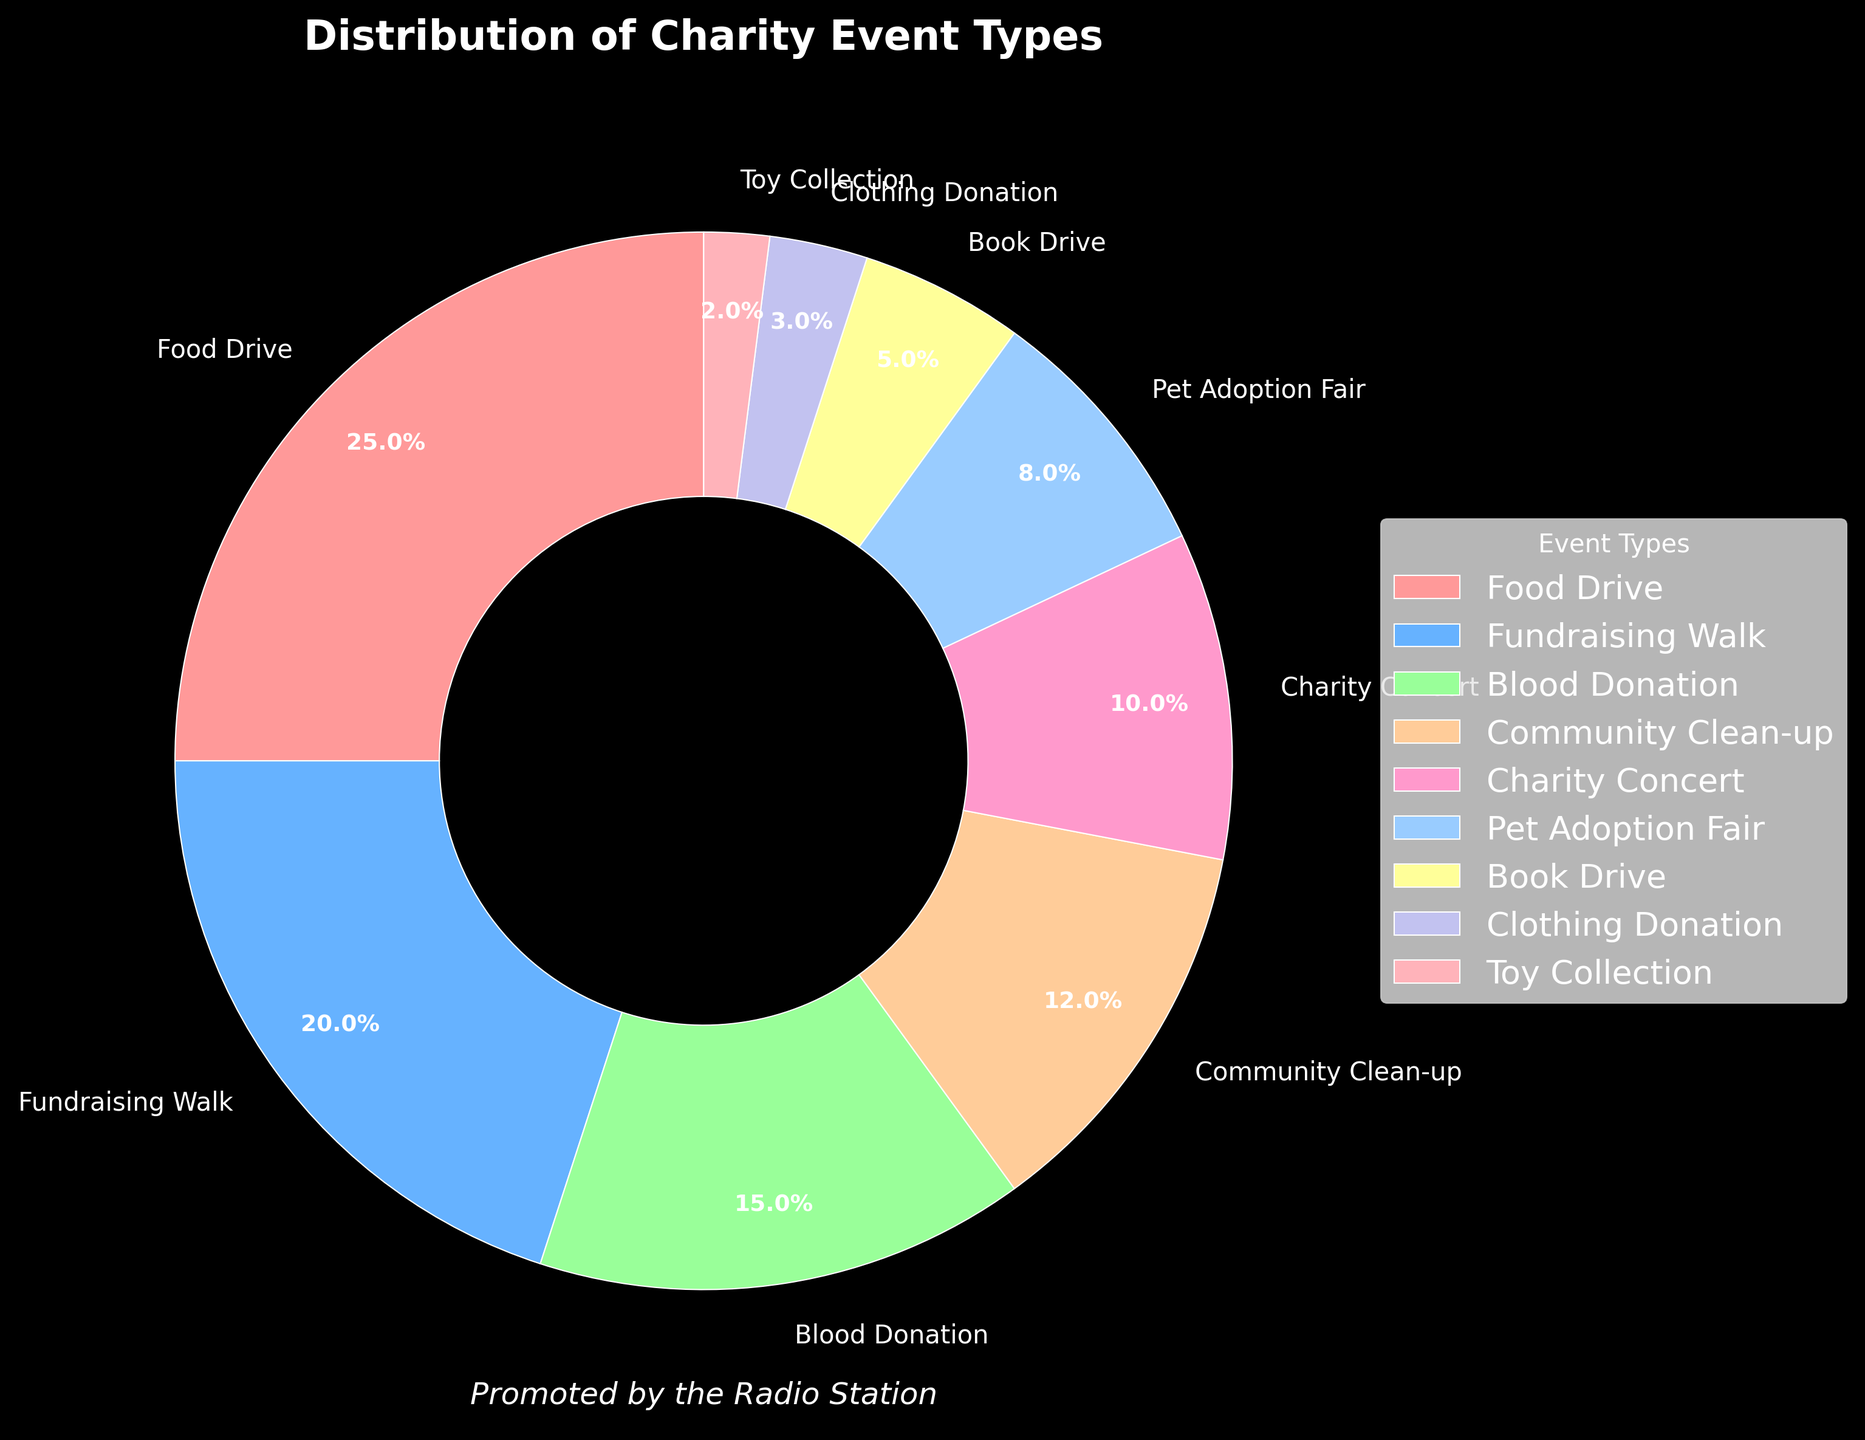What type of charity event has the highest percentage? The pie chart shows different charity event types with their respective percentage values. Observing the figure, "Food Drive" has the highest percentage of 25%.
Answer: Food Drive Compare the percentages of "Blood Donation" and "Charity Concert". Which type of event has a higher percentage and by how much? According to the pie chart, "Blood Donation" has 15% and "Charity Concert" has 10%. The difference between them is 15% - 10% = 5%.
Answer: Blood Donation by 5% What is the total percentage of Community Clean-up and Pet Adoption Fair combined? To find the total percentage of both events, sum their individual percentages. Community Clean-up is 12% and Pet Adoption Fair is 8%. Therefore, 12% + 8% = 20%.
Answer: 20% Which charity event type is represented by the pink wedge in the pie chart? The pink wedge on the pie chart corresponds to the "Food Drive", which is the event type with the highest percentage.
Answer: Food Drive How many event types have a percentage greater than or equal to 10%? List them. Observing the pie chart, the event types that meet this criterion are "Food Drive" (25%), "Fundraising Walk" (20%), "Blood Donation" (15%), "Community Clean-up" (12%), and "Charity Concert" (10%). Therefore, there are five event types.
Answer: Five: Food Drive, Fundraising Walk, Blood Donation, Community Clean-up, Charity Concert What is the difference in percentage between the event type with the highest percentage and the one with the lowest percentage? The event type with the highest percentage is "Food Drive" with 25%, and the lowest is "Toy Collection" with 2%. The difference is 25% - 2% = 23%.
Answer: 23% Do the total percentages of Food Drive, Fundraising Walk, and Blood Donation equal or exceed 50%? Adding the percentages for Food Drive (25%), Fundraising Walk (20%), and Blood Donation (15%), we get 25% + 20% + 15% = 60%, which exceeds 50%.
Answer: Exceed, 60% What color represents the "Book Drive" event type, and what is its percentage? The wedge for "Book Drive" is colored in yellow, as denoted in the pie chart. Its percentage is listed as 5%.
Answer: Yellow, 5% If the radio station wanted to focus on the top three event types by percentage, which would they be? The top three event types by percentage are "Food Drive" (25%), "Fundraising Walk" (20%), and "Blood Donation" (15%).
Answer: Food Drive, Fundraising Walk, Blood Donation 